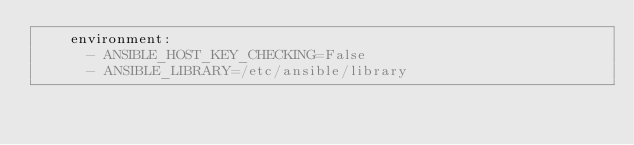<code> <loc_0><loc_0><loc_500><loc_500><_YAML_>    environment:
      - ANSIBLE_HOST_KEY_CHECKING=False
      - ANSIBLE_LIBRARY=/etc/ansible/library
</code> 